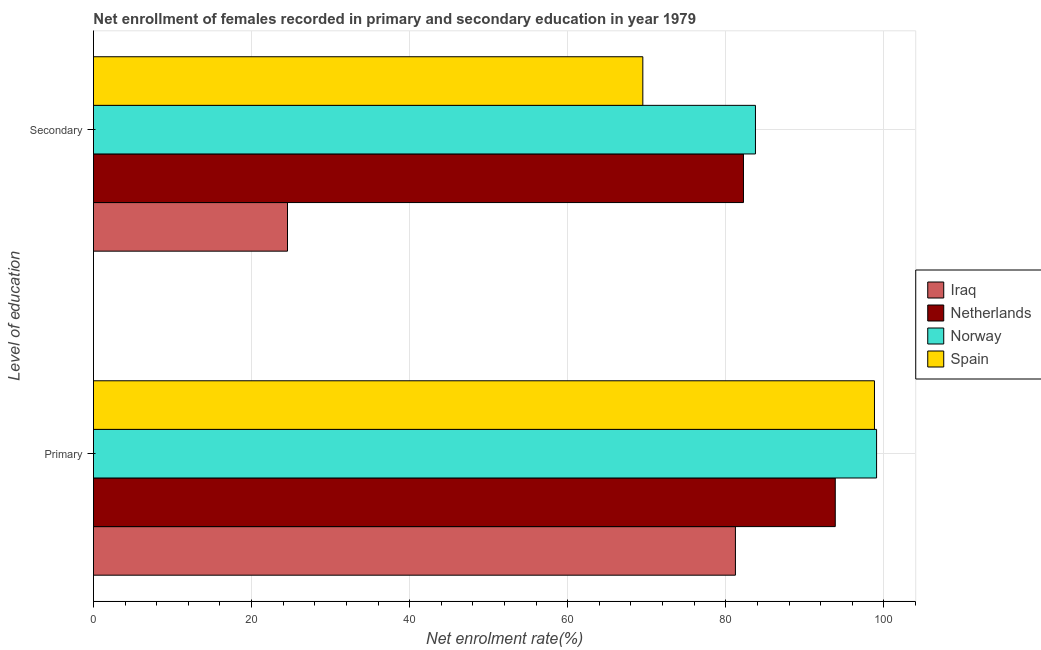How many groups of bars are there?
Your answer should be compact. 2. Are the number of bars on each tick of the Y-axis equal?
Provide a short and direct response. Yes. How many bars are there on the 1st tick from the top?
Your response must be concise. 4. What is the label of the 2nd group of bars from the top?
Provide a short and direct response. Primary. What is the enrollment rate in primary education in Spain?
Offer a very short reply. 98.81. Across all countries, what is the maximum enrollment rate in secondary education?
Provide a succinct answer. 83.75. Across all countries, what is the minimum enrollment rate in secondary education?
Provide a short and direct response. 24.55. In which country was the enrollment rate in secondary education maximum?
Your answer should be very brief. Norway. In which country was the enrollment rate in secondary education minimum?
Keep it short and to the point. Iraq. What is the total enrollment rate in secondary education in the graph?
Make the answer very short. 260.04. What is the difference between the enrollment rate in secondary education in Norway and that in Netherlands?
Provide a short and direct response. 1.52. What is the difference between the enrollment rate in secondary education in Netherlands and the enrollment rate in primary education in Norway?
Offer a very short reply. -16.84. What is the average enrollment rate in primary education per country?
Offer a very short reply. 93.24. What is the difference between the enrollment rate in secondary education and enrollment rate in primary education in Netherlands?
Ensure brevity in your answer.  -11.61. In how many countries, is the enrollment rate in secondary education greater than 92 %?
Your response must be concise. 0. What is the ratio of the enrollment rate in primary education in Norway to that in Netherlands?
Provide a succinct answer. 1.06. What does the 4th bar from the top in Primary represents?
Provide a short and direct response. Iraq. What does the 3rd bar from the bottom in Secondary represents?
Provide a succinct answer. Norway. Are all the bars in the graph horizontal?
Offer a very short reply. Yes. What is the difference between two consecutive major ticks on the X-axis?
Your answer should be compact. 20. Does the graph contain grids?
Keep it short and to the point. Yes. Where does the legend appear in the graph?
Keep it short and to the point. Center right. How are the legend labels stacked?
Your answer should be compact. Vertical. What is the title of the graph?
Your answer should be compact. Net enrollment of females recorded in primary and secondary education in year 1979. Does "Estonia" appear as one of the legend labels in the graph?
Your response must be concise. No. What is the label or title of the X-axis?
Offer a very short reply. Net enrolment rate(%). What is the label or title of the Y-axis?
Your answer should be very brief. Level of education. What is the Net enrolment rate(%) of Iraq in Primary?
Make the answer very short. 81.22. What is the Net enrolment rate(%) in Netherlands in Primary?
Give a very brief answer. 93.85. What is the Net enrolment rate(%) of Norway in Primary?
Provide a succinct answer. 99.07. What is the Net enrolment rate(%) of Spain in Primary?
Make the answer very short. 98.81. What is the Net enrolment rate(%) in Iraq in Secondary?
Offer a terse response. 24.55. What is the Net enrolment rate(%) of Netherlands in Secondary?
Keep it short and to the point. 82.24. What is the Net enrolment rate(%) of Norway in Secondary?
Provide a short and direct response. 83.75. What is the Net enrolment rate(%) of Spain in Secondary?
Your response must be concise. 69.5. Across all Level of education, what is the maximum Net enrolment rate(%) in Iraq?
Your answer should be compact. 81.22. Across all Level of education, what is the maximum Net enrolment rate(%) in Netherlands?
Provide a short and direct response. 93.85. Across all Level of education, what is the maximum Net enrolment rate(%) of Norway?
Make the answer very short. 99.07. Across all Level of education, what is the maximum Net enrolment rate(%) of Spain?
Keep it short and to the point. 98.81. Across all Level of education, what is the minimum Net enrolment rate(%) in Iraq?
Ensure brevity in your answer.  24.55. Across all Level of education, what is the minimum Net enrolment rate(%) of Netherlands?
Keep it short and to the point. 82.24. Across all Level of education, what is the minimum Net enrolment rate(%) of Norway?
Your response must be concise. 83.75. Across all Level of education, what is the minimum Net enrolment rate(%) in Spain?
Provide a short and direct response. 69.5. What is the total Net enrolment rate(%) in Iraq in the graph?
Provide a short and direct response. 105.76. What is the total Net enrolment rate(%) of Netherlands in the graph?
Ensure brevity in your answer.  176.08. What is the total Net enrolment rate(%) of Norway in the graph?
Your response must be concise. 182.82. What is the total Net enrolment rate(%) of Spain in the graph?
Your answer should be compact. 168.31. What is the difference between the Net enrolment rate(%) in Iraq in Primary and that in Secondary?
Offer a very short reply. 56.67. What is the difference between the Net enrolment rate(%) of Netherlands in Primary and that in Secondary?
Give a very brief answer. 11.61. What is the difference between the Net enrolment rate(%) of Norway in Primary and that in Secondary?
Offer a terse response. 15.32. What is the difference between the Net enrolment rate(%) of Spain in Primary and that in Secondary?
Your answer should be very brief. 29.31. What is the difference between the Net enrolment rate(%) of Iraq in Primary and the Net enrolment rate(%) of Netherlands in Secondary?
Provide a short and direct response. -1.02. What is the difference between the Net enrolment rate(%) in Iraq in Primary and the Net enrolment rate(%) in Norway in Secondary?
Offer a very short reply. -2.53. What is the difference between the Net enrolment rate(%) in Iraq in Primary and the Net enrolment rate(%) in Spain in Secondary?
Make the answer very short. 11.71. What is the difference between the Net enrolment rate(%) of Netherlands in Primary and the Net enrolment rate(%) of Norway in Secondary?
Your answer should be compact. 10.1. What is the difference between the Net enrolment rate(%) in Netherlands in Primary and the Net enrolment rate(%) in Spain in Secondary?
Offer a terse response. 24.35. What is the difference between the Net enrolment rate(%) in Norway in Primary and the Net enrolment rate(%) in Spain in Secondary?
Ensure brevity in your answer.  29.57. What is the average Net enrolment rate(%) in Iraq per Level of education?
Make the answer very short. 52.88. What is the average Net enrolment rate(%) of Netherlands per Level of education?
Provide a succinct answer. 88.04. What is the average Net enrolment rate(%) in Norway per Level of education?
Make the answer very short. 91.41. What is the average Net enrolment rate(%) in Spain per Level of education?
Provide a short and direct response. 84.15. What is the difference between the Net enrolment rate(%) in Iraq and Net enrolment rate(%) in Netherlands in Primary?
Provide a short and direct response. -12.63. What is the difference between the Net enrolment rate(%) of Iraq and Net enrolment rate(%) of Norway in Primary?
Give a very brief answer. -17.86. What is the difference between the Net enrolment rate(%) in Iraq and Net enrolment rate(%) in Spain in Primary?
Keep it short and to the point. -17.59. What is the difference between the Net enrolment rate(%) of Netherlands and Net enrolment rate(%) of Norway in Primary?
Your response must be concise. -5.22. What is the difference between the Net enrolment rate(%) in Netherlands and Net enrolment rate(%) in Spain in Primary?
Make the answer very short. -4.96. What is the difference between the Net enrolment rate(%) in Norway and Net enrolment rate(%) in Spain in Primary?
Offer a very short reply. 0.27. What is the difference between the Net enrolment rate(%) in Iraq and Net enrolment rate(%) in Netherlands in Secondary?
Provide a short and direct response. -57.69. What is the difference between the Net enrolment rate(%) in Iraq and Net enrolment rate(%) in Norway in Secondary?
Offer a terse response. -59.2. What is the difference between the Net enrolment rate(%) in Iraq and Net enrolment rate(%) in Spain in Secondary?
Your answer should be compact. -44.95. What is the difference between the Net enrolment rate(%) of Netherlands and Net enrolment rate(%) of Norway in Secondary?
Offer a terse response. -1.52. What is the difference between the Net enrolment rate(%) of Netherlands and Net enrolment rate(%) of Spain in Secondary?
Your answer should be compact. 12.73. What is the difference between the Net enrolment rate(%) in Norway and Net enrolment rate(%) in Spain in Secondary?
Ensure brevity in your answer.  14.25. What is the ratio of the Net enrolment rate(%) in Iraq in Primary to that in Secondary?
Provide a short and direct response. 3.31. What is the ratio of the Net enrolment rate(%) of Netherlands in Primary to that in Secondary?
Make the answer very short. 1.14. What is the ratio of the Net enrolment rate(%) in Norway in Primary to that in Secondary?
Your response must be concise. 1.18. What is the ratio of the Net enrolment rate(%) of Spain in Primary to that in Secondary?
Make the answer very short. 1.42. What is the difference between the highest and the second highest Net enrolment rate(%) in Iraq?
Your answer should be very brief. 56.67. What is the difference between the highest and the second highest Net enrolment rate(%) in Netherlands?
Provide a short and direct response. 11.61. What is the difference between the highest and the second highest Net enrolment rate(%) of Norway?
Ensure brevity in your answer.  15.32. What is the difference between the highest and the second highest Net enrolment rate(%) of Spain?
Your answer should be compact. 29.31. What is the difference between the highest and the lowest Net enrolment rate(%) in Iraq?
Your answer should be very brief. 56.67. What is the difference between the highest and the lowest Net enrolment rate(%) of Netherlands?
Your answer should be very brief. 11.61. What is the difference between the highest and the lowest Net enrolment rate(%) in Norway?
Your response must be concise. 15.32. What is the difference between the highest and the lowest Net enrolment rate(%) in Spain?
Your answer should be very brief. 29.31. 